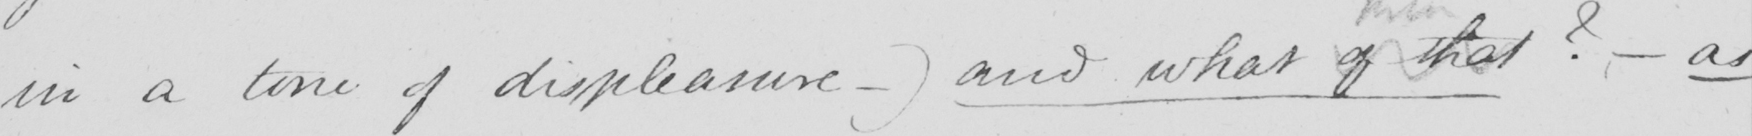What text is written in this handwritten line? in a tone of displeasure  _  )  and what of that  ?   _  as 